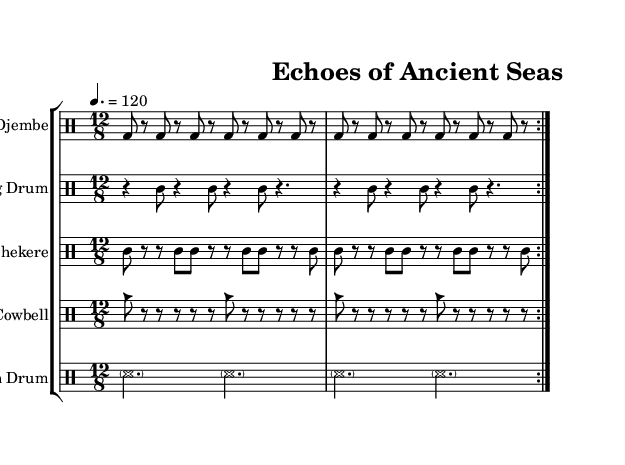What is the time signature of this music? The time signature is indicated at the beginning of the score as 12/8, which means there are 12 eighth notes in each measure.
Answer: 12/8 What is the tempo marking for this composition? The tempo is specified as "4. = 120," indicating that there are 120 beats per minute and each beat corresponds to a quarter note.
Answer: 120 How many instruments are featured in this piece? The score presents five distinct drum parts, as indicated by the separate drum staff for each instrument: Djembe, Talking Drum, Shekere, Cowbell, and Ocean Drum.
Answer: Five What does the "tt" represent in the Talking Drum part? The "tt" indicates a technique of playing that involves tapping the drum quickly, which is characteristic of the Talking Drum’s rhythm patterns.
Answer: Tap Which instrument's rhythm features the pattern "mar" in the sheet music? The "mar" pattern is found in the Shekere rhythm, representing the shaking sound associated with this African percussion instrument.
Answer: Shekere Explain the significance of the Ocean Drum's notation. The Ocean Drum part uses long, sustained sounds represented by "ss" and dotted half notes, suggesting a flowing, wave-like rhythm that echoes the marine theme. This aligns with the composition's inspiration drawn from prehistoric marine life.
Answer: Wave-like rhythm 